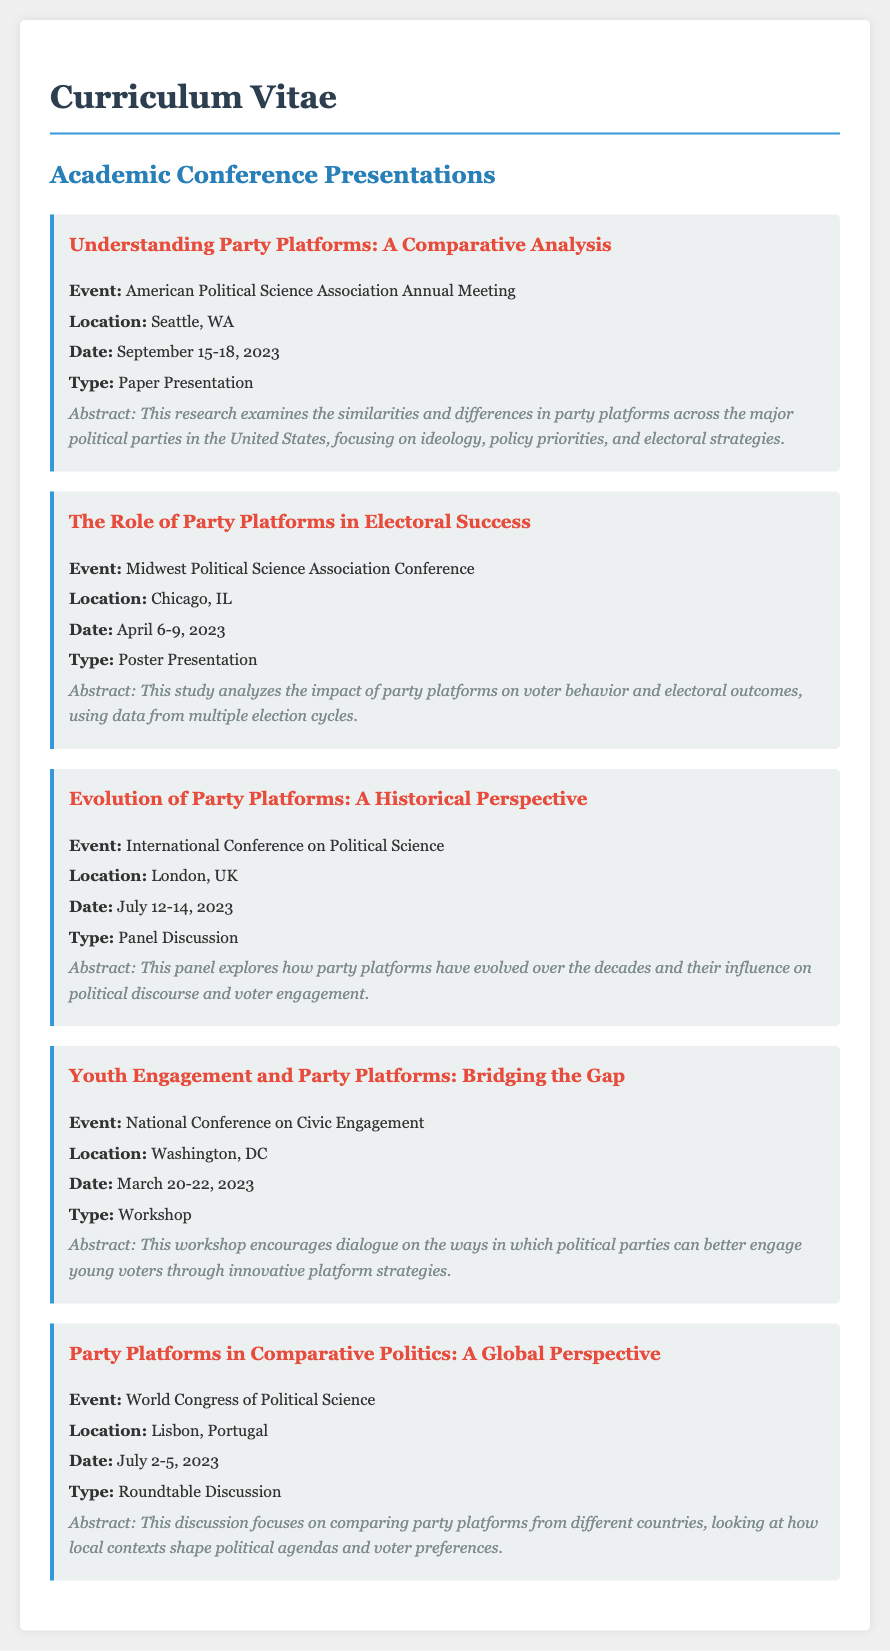What was the title of the first presentation? The title of the first presentation is listed under the first conference in the document.
Answer: Understanding Party Platforms: A Comparative Analysis Where was the Midwest Political Science Association Conference held? The location of the conference is specified in the document.
Answer: Chicago, IL Which event featured a workshop on engaging young voters? The specific event is mentioned in the section detailing conferences, indicating the type of presentation.
Answer: National Conference on Civic Engagement What date did the World Congress of Political Science occur? The date for this event is explicitly stated in the document.
Answer: July 2-5, 2023 How many conferences are listed in the document? The total number of conferences can be counted from the sections provided.
Answer: Five What is the main focus of the paper presented at the American Political Science Association Annual Meeting? The abstract of the presentation provides insight into its focus by summarizing the content.
Answer: Comparative analysis of party platforms Which presentation type was featured in the London conference? The type of presentation at that event is indicated directly in the text.
Answer: Panel Discussion What common theme is highlighted across multiple presentations? Reasoning from the content can deduce recurring themes across the conferences.
Answer: Party platforms Who participated in the roundtable discussion on comparative politics? The specific participants are typically not detailed in CV presentations; however, the topic indicates a focus area.
Answer: Comparative politics (general theme) 